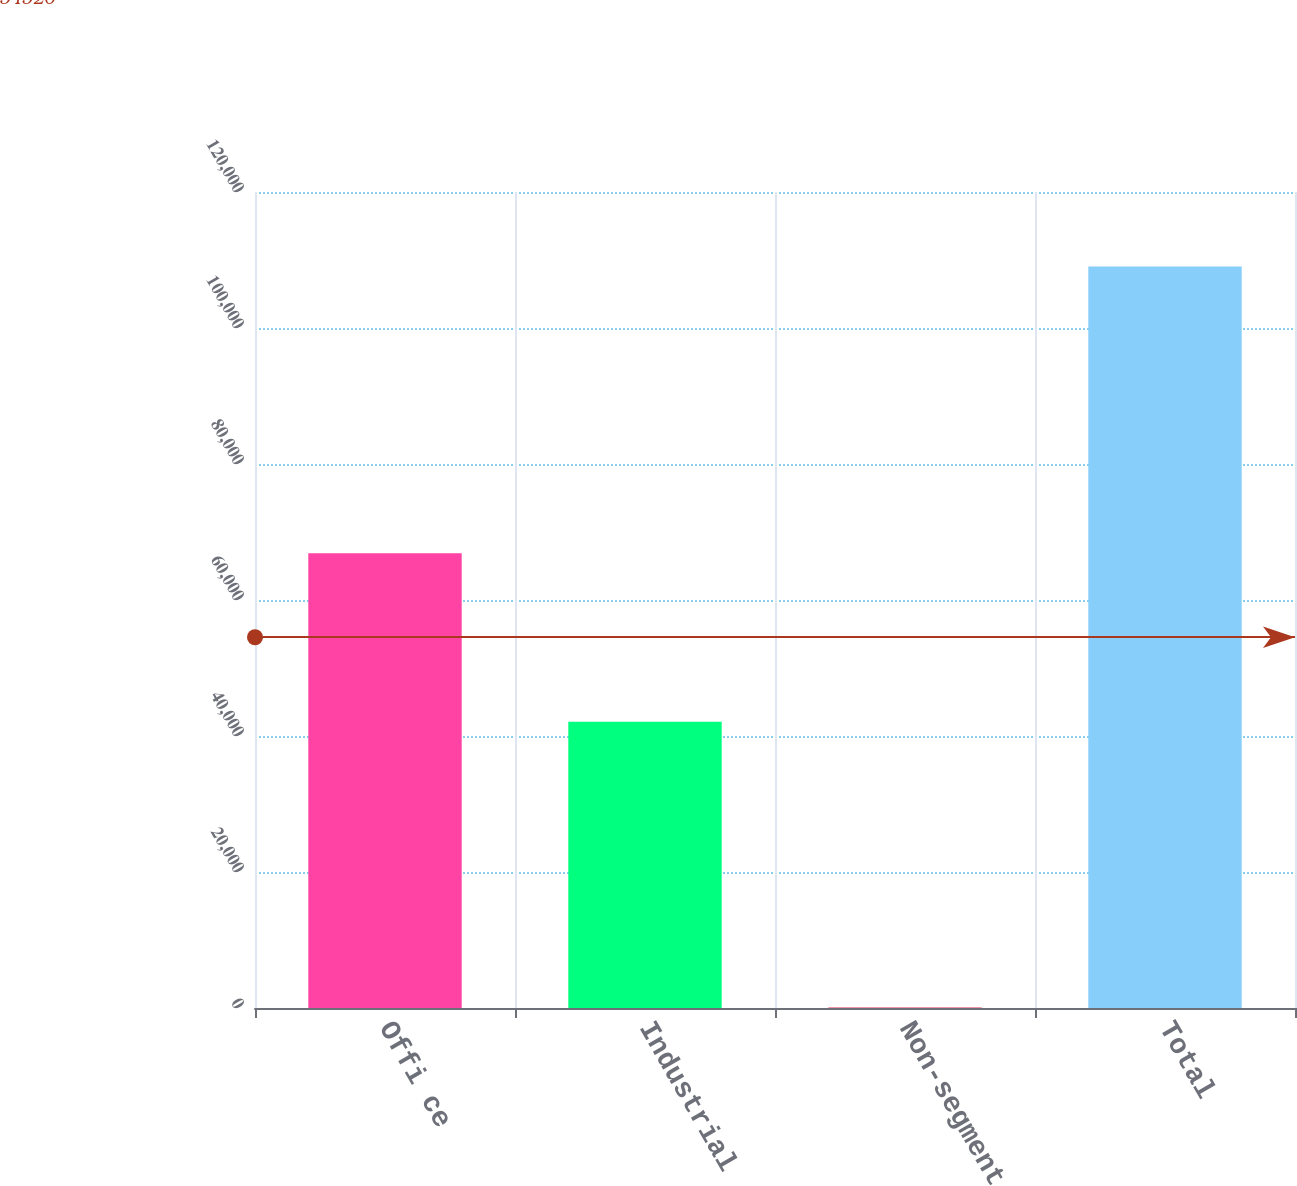Convert chart. <chart><loc_0><loc_0><loc_500><loc_500><bar_chart><fcel>Offi ce<fcel>Industrial<fcel>Non-segment<fcel>Total<nl><fcel>66890<fcel>42083<fcel>67<fcel>109040<nl></chart> 